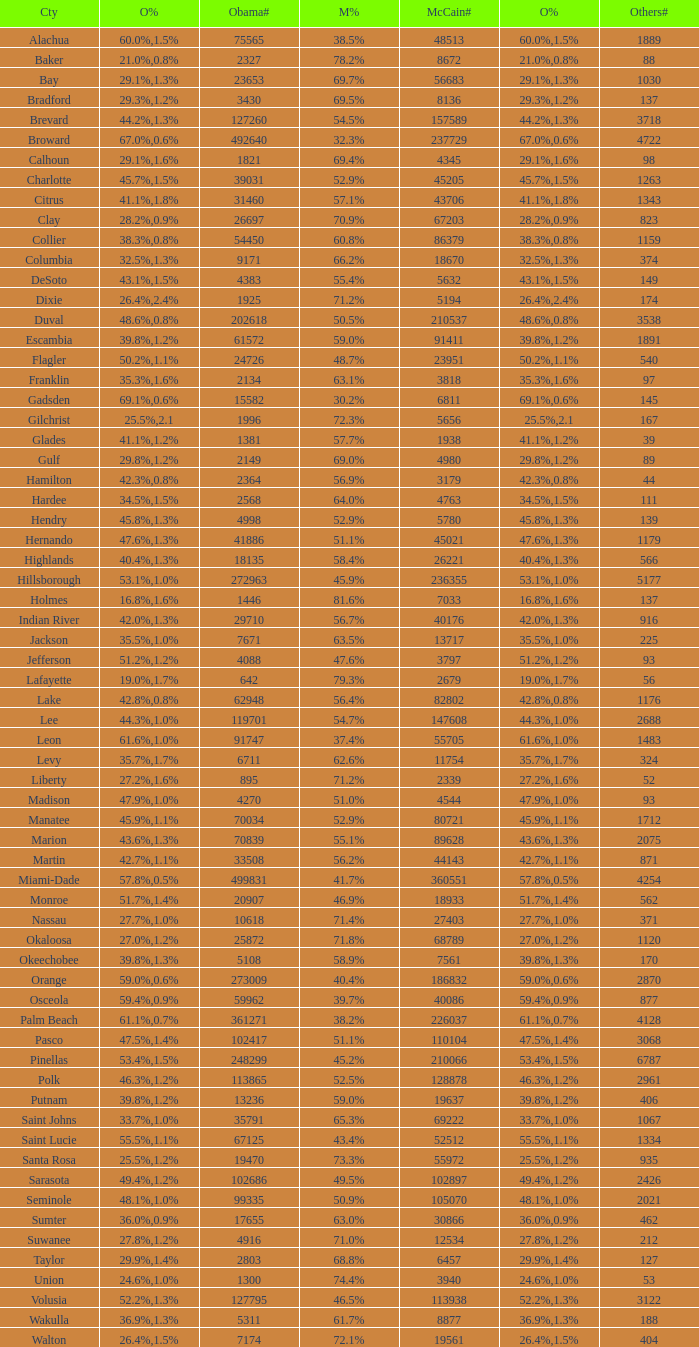What were the number of voters McCain had when Obama had 895? 2339.0. 